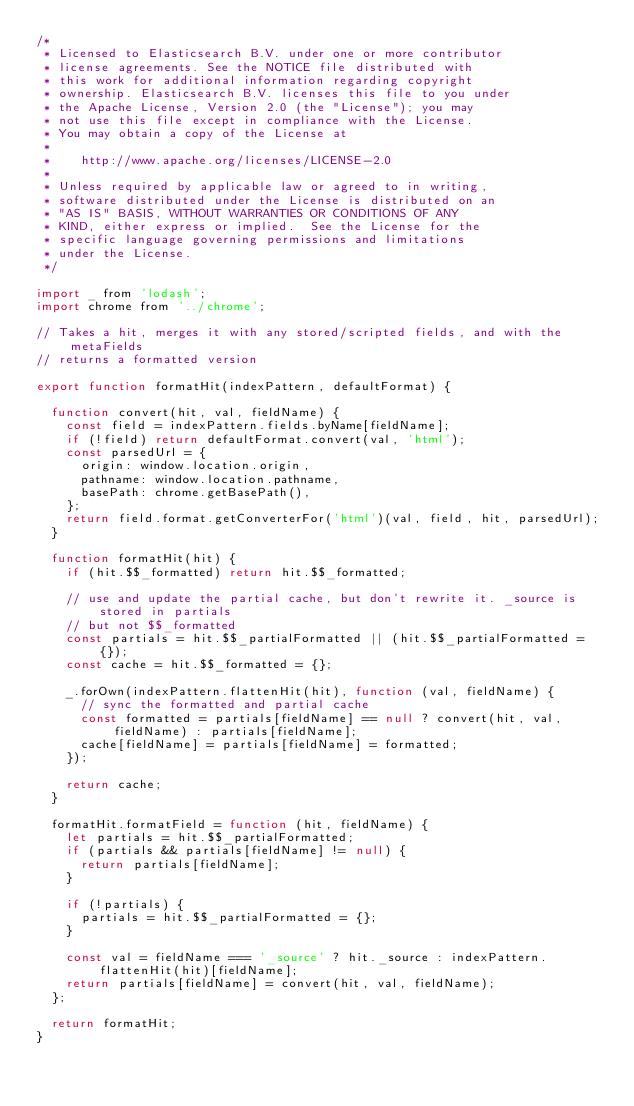Convert code to text. <code><loc_0><loc_0><loc_500><loc_500><_JavaScript_>/*
 * Licensed to Elasticsearch B.V. under one or more contributor
 * license agreements. See the NOTICE file distributed with
 * this work for additional information regarding copyright
 * ownership. Elasticsearch B.V. licenses this file to you under
 * the Apache License, Version 2.0 (the "License"); you may
 * not use this file except in compliance with the License.
 * You may obtain a copy of the License at
 *
 *    http://www.apache.org/licenses/LICENSE-2.0
 *
 * Unless required by applicable law or agreed to in writing,
 * software distributed under the License is distributed on an
 * "AS IS" BASIS, WITHOUT WARRANTIES OR CONDITIONS OF ANY
 * KIND, either express or implied.  See the License for the
 * specific language governing permissions and limitations
 * under the License.
 */

import _ from 'lodash';
import chrome from '../chrome';

// Takes a hit, merges it with any stored/scripted fields, and with the metaFields
// returns a formatted version

export function formatHit(indexPattern, defaultFormat) {

  function convert(hit, val, fieldName) {
    const field = indexPattern.fields.byName[fieldName];
    if (!field) return defaultFormat.convert(val, 'html');
    const parsedUrl = {
      origin: window.location.origin,
      pathname: window.location.pathname,
      basePath: chrome.getBasePath(),
    };
    return field.format.getConverterFor('html')(val, field, hit, parsedUrl);
  }

  function formatHit(hit) {
    if (hit.$$_formatted) return hit.$$_formatted;

    // use and update the partial cache, but don't rewrite it. _source is stored in partials
    // but not $$_formatted
    const partials = hit.$$_partialFormatted || (hit.$$_partialFormatted = {});
    const cache = hit.$$_formatted = {};

    _.forOwn(indexPattern.flattenHit(hit), function (val, fieldName) {
      // sync the formatted and partial cache
      const formatted = partials[fieldName] == null ? convert(hit, val, fieldName) : partials[fieldName];
      cache[fieldName] = partials[fieldName] = formatted;
    });

    return cache;
  }

  formatHit.formatField = function (hit, fieldName) {
    let partials = hit.$$_partialFormatted;
    if (partials && partials[fieldName] != null) {
      return partials[fieldName];
    }

    if (!partials) {
      partials = hit.$$_partialFormatted = {};
    }

    const val = fieldName === '_source' ? hit._source : indexPattern.flattenHit(hit)[fieldName];
    return partials[fieldName] = convert(hit, val, fieldName);
  };

  return formatHit;
}

</code> 